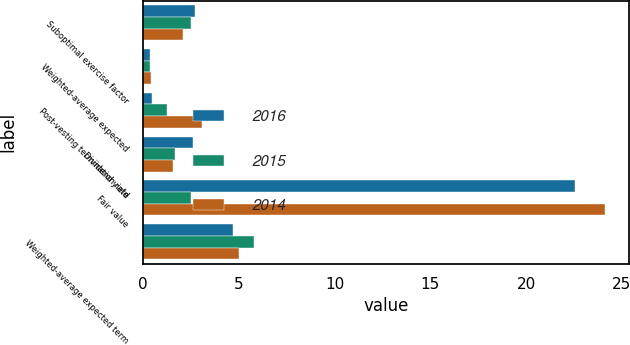Convert chart to OTSL. <chart><loc_0><loc_0><loc_500><loc_500><stacked_bar_chart><ecel><fcel>Suboptimal exercise factor<fcel>Weighted-average expected<fcel>Post-vesting termination rate<fcel>Dividend yield<fcel>Fair value<fcel>Weighted-average expected term<nl><fcel>2016<fcel>2.71<fcel>0.35<fcel>0.47<fcel>2.61<fcel>22.54<fcel>4.7<nl><fcel>2015<fcel>2.52<fcel>0.36<fcel>1.25<fcel>1.69<fcel>2.52<fcel>5.8<nl><fcel>2014<fcel>2.07<fcel>0.43<fcel>3.1<fcel>1.58<fcel>24.14<fcel>5<nl></chart> 